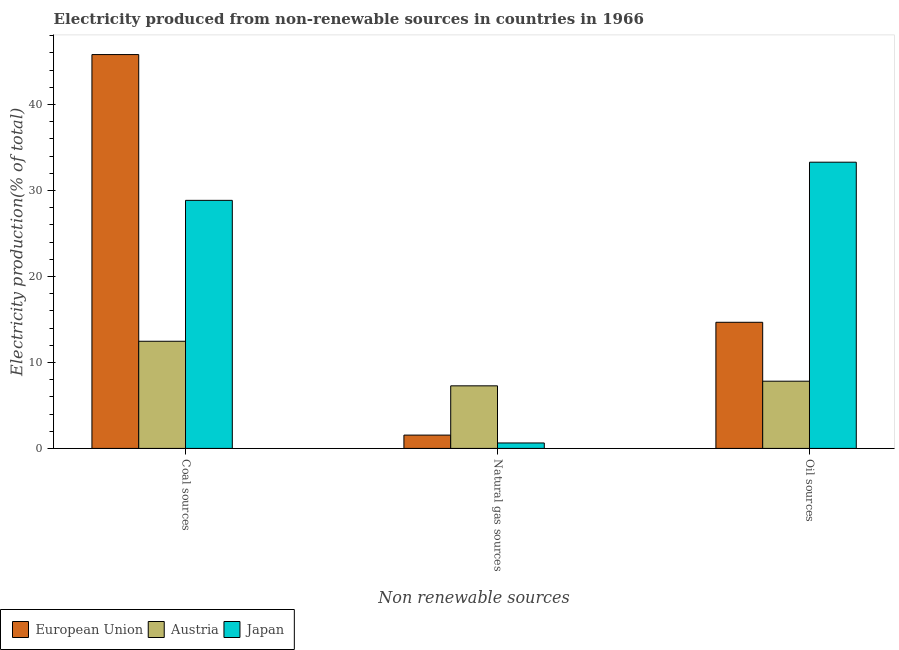How many bars are there on the 1st tick from the left?
Offer a very short reply. 3. What is the label of the 3rd group of bars from the left?
Offer a very short reply. Oil sources. What is the percentage of electricity produced by natural gas in Japan?
Keep it short and to the point. 0.63. Across all countries, what is the maximum percentage of electricity produced by coal?
Give a very brief answer. 45.82. Across all countries, what is the minimum percentage of electricity produced by oil sources?
Your answer should be compact. 7.82. In which country was the percentage of electricity produced by coal maximum?
Make the answer very short. European Union. What is the total percentage of electricity produced by natural gas in the graph?
Offer a terse response. 9.46. What is the difference between the percentage of electricity produced by coal in European Union and that in Japan?
Your answer should be very brief. 16.96. What is the difference between the percentage of electricity produced by oil sources in Austria and the percentage of electricity produced by coal in Japan?
Your answer should be very brief. -21.04. What is the average percentage of electricity produced by oil sources per country?
Your answer should be very brief. 18.6. What is the difference between the percentage of electricity produced by oil sources and percentage of electricity produced by natural gas in Austria?
Provide a succinct answer. 0.54. What is the ratio of the percentage of electricity produced by oil sources in Japan to that in European Union?
Offer a very short reply. 2.27. Is the percentage of electricity produced by natural gas in European Union less than that in Japan?
Provide a short and direct response. No. What is the difference between the highest and the second highest percentage of electricity produced by natural gas?
Give a very brief answer. 5.73. What is the difference between the highest and the lowest percentage of electricity produced by coal?
Give a very brief answer. 33.35. In how many countries, is the percentage of electricity produced by natural gas greater than the average percentage of electricity produced by natural gas taken over all countries?
Provide a short and direct response. 1. Are all the bars in the graph horizontal?
Your answer should be compact. No. How many countries are there in the graph?
Provide a short and direct response. 3. What is the difference between two consecutive major ticks on the Y-axis?
Keep it short and to the point. 10. Does the graph contain any zero values?
Provide a succinct answer. No. Does the graph contain grids?
Offer a very short reply. No. What is the title of the graph?
Give a very brief answer. Electricity produced from non-renewable sources in countries in 1966. Does "Luxembourg" appear as one of the legend labels in the graph?
Give a very brief answer. No. What is the label or title of the X-axis?
Keep it short and to the point. Non renewable sources. What is the label or title of the Y-axis?
Make the answer very short. Electricity production(% of total). What is the Electricity production(% of total) of European Union in Coal sources?
Your answer should be compact. 45.82. What is the Electricity production(% of total) of Austria in Coal sources?
Ensure brevity in your answer.  12.47. What is the Electricity production(% of total) of Japan in Coal sources?
Ensure brevity in your answer.  28.86. What is the Electricity production(% of total) in European Union in Natural gas sources?
Keep it short and to the point. 1.55. What is the Electricity production(% of total) in Austria in Natural gas sources?
Your answer should be compact. 7.28. What is the Electricity production(% of total) of Japan in Natural gas sources?
Keep it short and to the point. 0.63. What is the Electricity production(% of total) of European Union in Oil sources?
Make the answer very short. 14.67. What is the Electricity production(% of total) of Austria in Oil sources?
Give a very brief answer. 7.82. What is the Electricity production(% of total) in Japan in Oil sources?
Offer a terse response. 33.3. Across all Non renewable sources, what is the maximum Electricity production(% of total) in European Union?
Ensure brevity in your answer.  45.82. Across all Non renewable sources, what is the maximum Electricity production(% of total) of Austria?
Provide a short and direct response. 12.47. Across all Non renewable sources, what is the maximum Electricity production(% of total) of Japan?
Keep it short and to the point. 33.3. Across all Non renewable sources, what is the minimum Electricity production(% of total) of European Union?
Your answer should be compact. 1.55. Across all Non renewable sources, what is the minimum Electricity production(% of total) in Austria?
Give a very brief answer. 7.28. Across all Non renewable sources, what is the minimum Electricity production(% of total) of Japan?
Your response must be concise. 0.63. What is the total Electricity production(% of total) of European Union in the graph?
Offer a very short reply. 62.04. What is the total Electricity production(% of total) in Austria in the graph?
Give a very brief answer. 27.57. What is the total Electricity production(% of total) in Japan in the graph?
Your answer should be compact. 62.79. What is the difference between the Electricity production(% of total) in European Union in Coal sources and that in Natural gas sources?
Your response must be concise. 44.27. What is the difference between the Electricity production(% of total) in Austria in Coal sources and that in Natural gas sources?
Your answer should be very brief. 5.19. What is the difference between the Electricity production(% of total) of Japan in Coal sources and that in Natural gas sources?
Give a very brief answer. 28.22. What is the difference between the Electricity production(% of total) in European Union in Coal sources and that in Oil sources?
Make the answer very short. 31.14. What is the difference between the Electricity production(% of total) of Austria in Coal sources and that in Oil sources?
Provide a succinct answer. 4.65. What is the difference between the Electricity production(% of total) of Japan in Coal sources and that in Oil sources?
Your answer should be very brief. -4.44. What is the difference between the Electricity production(% of total) of European Union in Natural gas sources and that in Oil sources?
Offer a very short reply. -13.12. What is the difference between the Electricity production(% of total) in Austria in Natural gas sources and that in Oil sources?
Your response must be concise. -0.54. What is the difference between the Electricity production(% of total) of Japan in Natural gas sources and that in Oil sources?
Your answer should be very brief. -32.66. What is the difference between the Electricity production(% of total) of European Union in Coal sources and the Electricity production(% of total) of Austria in Natural gas sources?
Your answer should be compact. 38.54. What is the difference between the Electricity production(% of total) in European Union in Coal sources and the Electricity production(% of total) in Japan in Natural gas sources?
Ensure brevity in your answer.  45.18. What is the difference between the Electricity production(% of total) in Austria in Coal sources and the Electricity production(% of total) in Japan in Natural gas sources?
Offer a very short reply. 11.83. What is the difference between the Electricity production(% of total) in European Union in Coal sources and the Electricity production(% of total) in Austria in Oil sources?
Provide a short and direct response. 38. What is the difference between the Electricity production(% of total) in European Union in Coal sources and the Electricity production(% of total) in Japan in Oil sources?
Keep it short and to the point. 12.52. What is the difference between the Electricity production(% of total) in Austria in Coal sources and the Electricity production(% of total) in Japan in Oil sources?
Your answer should be compact. -20.83. What is the difference between the Electricity production(% of total) in European Union in Natural gas sources and the Electricity production(% of total) in Austria in Oil sources?
Provide a short and direct response. -6.27. What is the difference between the Electricity production(% of total) in European Union in Natural gas sources and the Electricity production(% of total) in Japan in Oil sources?
Ensure brevity in your answer.  -31.75. What is the difference between the Electricity production(% of total) of Austria in Natural gas sources and the Electricity production(% of total) of Japan in Oil sources?
Ensure brevity in your answer.  -26.02. What is the average Electricity production(% of total) in European Union per Non renewable sources?
Provide a succinct answer. 20.68. What is the average Electricity production(% of total) in Austria per Non renewable sources?
Give a very brief answer. 9.19. What is the average Electricity production(% of total) of Japan per Non renewable sources?
Offer a terse response. 20.93. What is the difference between the Electricity production(% of total) in European Union and Electricity production(% of total) in Austria in Coal sources?
Make the answer very short. 33.35. What is the difference between the Electricity production(% of total) of European Union and Electricity production(% of total) of Japan in Coal sources?
Provide a short and direct response. 16.96. What is the difference between the Electricity production(% of total) in Austria and Electricity production(% of total) in Japan in Coal sources?
Your response must be concise. -16.39. What is the difference between the Electricity production(% of total) in European Union and Electricity production(% of total) in Austria in Natural gas sources?
Your response must be concise. -5.73. What is the difference between the Electricity production(% of total) of European Union and Electricity production(% of total) of Japan in Natural gas sources?
Offer a terse response. 0.91. What is the difference between the Electricity production(% of total) in Austria and Electricity production(% of total) in Japan in Natural gas sources?
Keep it short and to the point. 6.65. What is the difference between the Electricity production(% of total) of European Union and Electricity production(% of total) of Austria in Oil sources?
Give a very brief answer. 6.85. What is the difference between the Electricity production(% of total) in European Union and Electricity production(% of total) in Japan in Oil sources?
Ensure brevity in your answer.  -18.62. What is the difference between the Electricity production(% of total) of Austria and Electricity production(% of total) of Japan in Oil sources?
Your response must be concise. -25.48. What is the ratio of the Electricity production(% of total) of European Union in Coal sources to that in Natural gas sources?
Your answer should be very brief. 29.59. What is the ratio of the Electricity production(% of total) in Austria in Coal sources to that in Natural gas sources?
Your answer should be very brief. 1.71. What is the ratio of the Electricity production(% of total) in Japan in Coal sources to that in Natural gas sources?
Offer a very short reply. 45.52. What is the ratio of the Electricity production(% of total) of European Union in Coal sources to that in Oil sources?
Provide a short and direct response. 3.12. What is the ratio of the Electricity production(% of total) of Austria in Coal sources to that in Oil sources?
Your answer should be compact. 1.59. What is the ratio of the Electricity production(% of total) in Japan in Coal sources to that in Oil sources?
Provide a succinct answer. 0.87. What is the ratio of the Electricity production(% of total) of European Union in Natural gas sources to that in Oil sources?
Provide a short and direct response. 0.11. What is the ratio of the Electricity production(% of total) in Japan in Natural gas sources to that in Oil sources?
Provide a short and direct response. 0.02. What is the difference between the highest and the second highest Electricity production(% of total) of European Union?
Give a very brief answer. 31.14. What is the difference between the highest and the second highest Electricity production(% of total) in Austria?
Your answer should be compact. 4.65. What is the difference between the highest and the second highest Electricity production(% of total) in Japan?
Keep it short and to the point. 4.44. What is the difference between the highest and the lowest Electricity production(% of total) in European Union?
Keep it short and to the point. 44.27. What is the difference between the highest and the lowest Electricity production(% of total) in Austria?
Your answer should be very brief. 5.19. What is the difference between the highest and the lowest Electricity production(% of total) of Japan?
Provide a succinct answer. 32.66. 